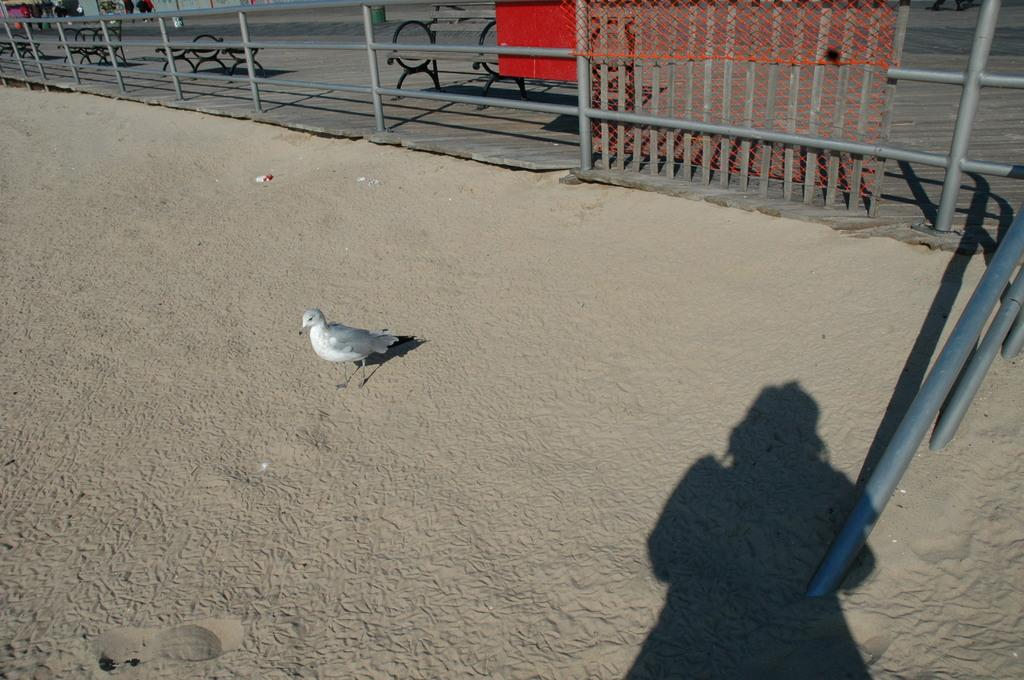What can be seen in the image that resembles a person? There is a shadow of a person in the image. What animal is present on the road in the image? There is a bird on the road in the image. What type of architectural feature is visible in the background of the image? There is fencing in the background of the image. What type of seating is visible in the background of the image? There are benches in the background of the image. What type of surface is visible in the image? There is a road visible in the image. What type of wool is being used to create the shadow in the image? There is no wool present in the image; the shadow is created by the person blocking the light. How does the rainstorm affect the bird on the road in the image? There is no rainstorm present in the image; it only features a bird on the road. 